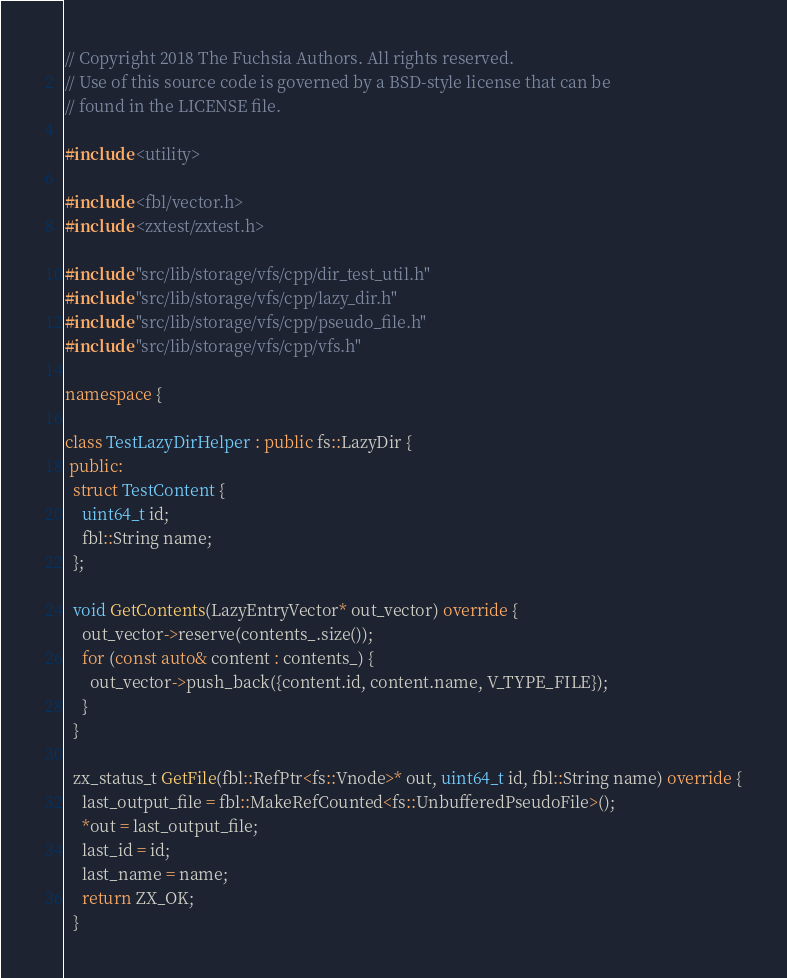Convert code to text. <code><loc_0><loc_0><loc_500><loc_500><_C++_>// Copyright 2018 The Fuchsia Authors. All rights reserved.
// Use of this source code is governed by a BSD-style license that can be
// found in the LICENSE file.

#include <utility>

#include <fbl/vector.h>
#include <zxtest/zxtest.h>

#include "src/lib/storage/vfs/cpp/dir_test_util.h"
#include "src/lib/storage/vfs/cpp/lazy_dir.h"
#include "src/lib/storage/vfs/cpp/pseudo_file.h"
#include "src/lib/storage/vfs/cpp/vfs.h"

namespace {

class TestLazyDirHelper : public fs::LazyDir {
 public:
  struct TestContent {
    uint64_t id;
    fbl::String name;
  };

  void GetContents(LazyEntryVector* out_vector) override {
    out_vector->reserve(contents_.size());
    for (const auto& content : contents_) {
      out_vector->push_back({content.id, content.name, V_TYPE_FILE});
    }
  }

  zx_status_t GetFile(fbl::RefPtr<fs::Vnode>* out, uint64_t id, fbl::String name) override {
    last_output_file = fbl::MakeRefCounted<fs::UnbufferedPseudoFile>();
    *out = last_output_file;
    last_id = id;
    last_name = name;
    return ZX_OK;
  }
</code> 